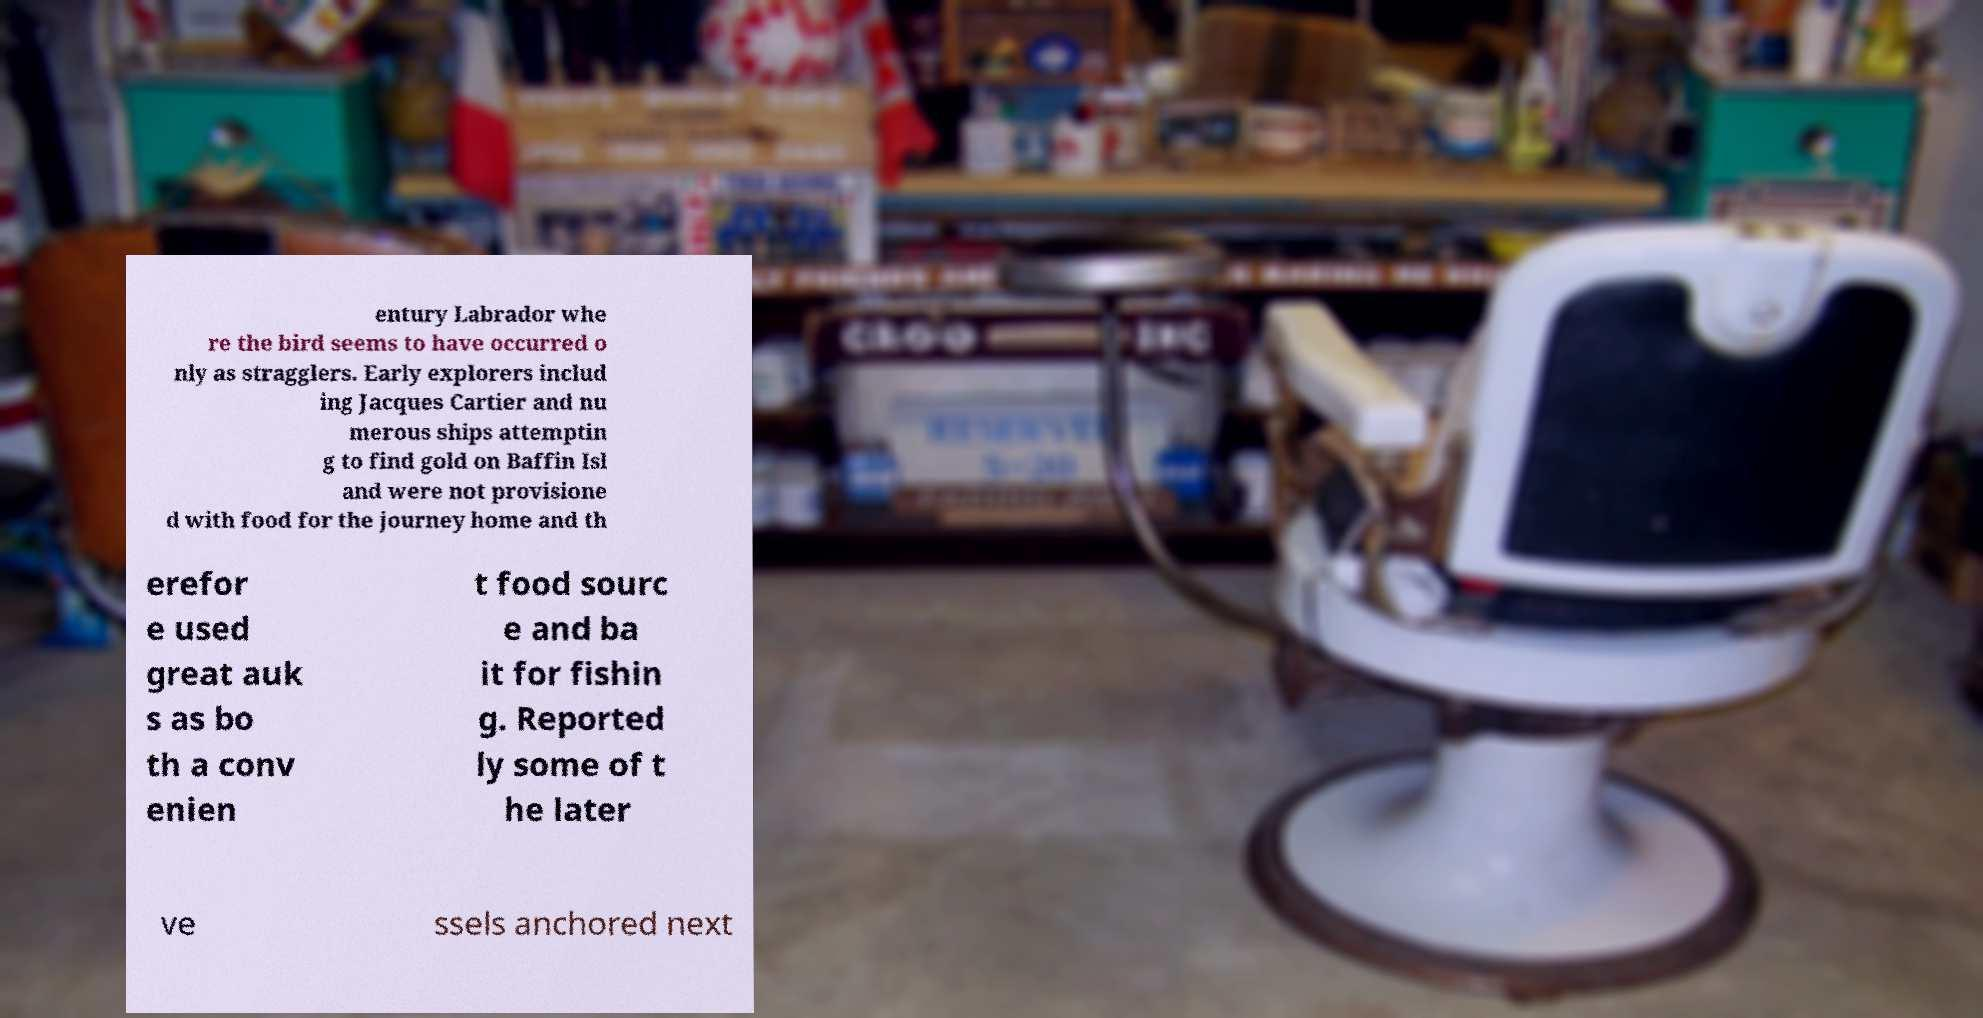There's text embedded in this image that I need extracted. Can you transcribe it verbatim? entury Labrador whe re the bird seems to have occurred o nly as stragglers. Early explorers includ ing Jacques Cartier and nu merous ships attemptin g to find gold on Baffin Isl and were not provisione d with food for the journey home and th erefor e used great auk s as bo th a conv enien t food sourc e and ba it for fishin g. Reported ly some of t he later ve ssels anchored next 